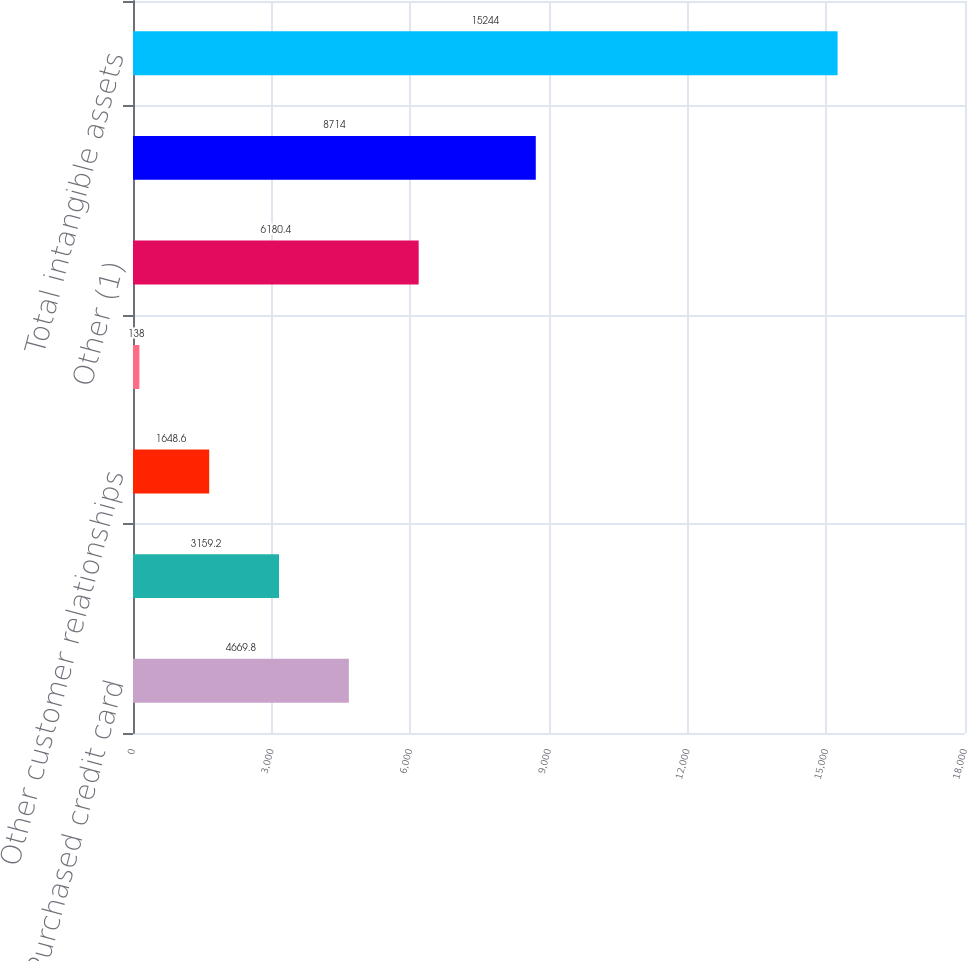Convert chart. <chart><loc_0><loc_0><loc_500><loc_500><bar_chart><fcel>Purchased credit card<fcel>Core deposit intangibles<fcel>Other customer relationships<fcel>Present value of future<fcel>Other (1)<fcel>Intangible assets (excluding<fcel>Total intangible assets<nl><fcel>4669.8<fcel>3159.2<fcel>1648.6<fcel>138<fcel>6180.4<fcel>8714<fcel>15244<nl></chart> 